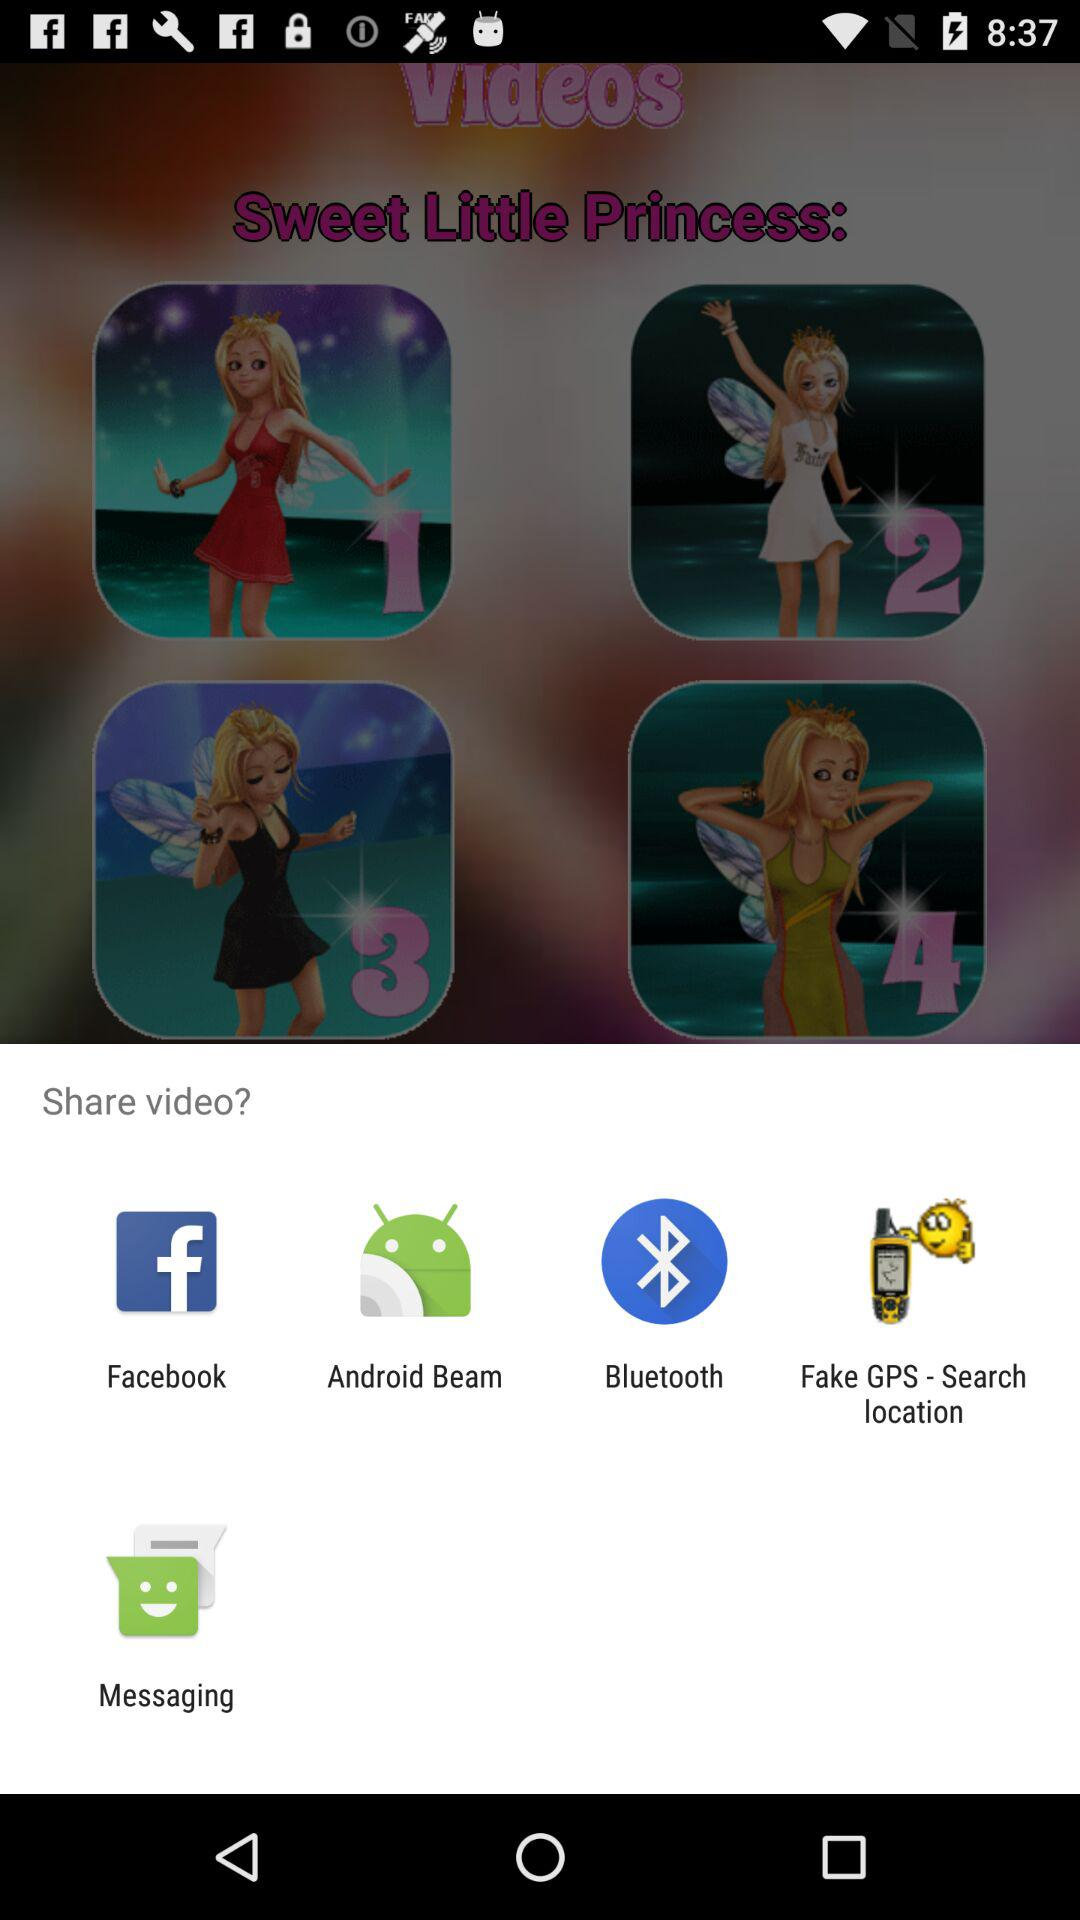Which "Sweet Little Princess" video is selected for sharing?
When the provided information is insufficient, respond with <no answer>. <no answer> 